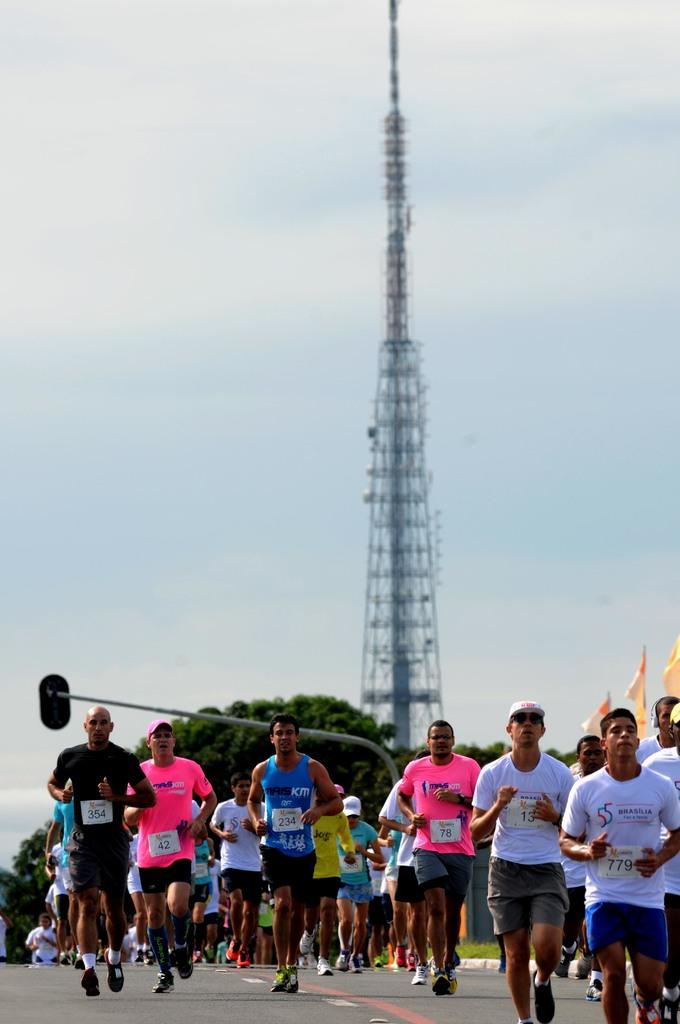What are the people in the image doing? People are running on the road in the image. What can be seen in the background of the image? There is a tower, trees, flags, a signal light pole, and a cloudy sky in the background of the image. What type of jeans are the people wearing while teaching in the image? There is no teaching or jeans present in the image; people are running on the road. Is there a bridge visible in the image? No, there is no bridge present in the image. 